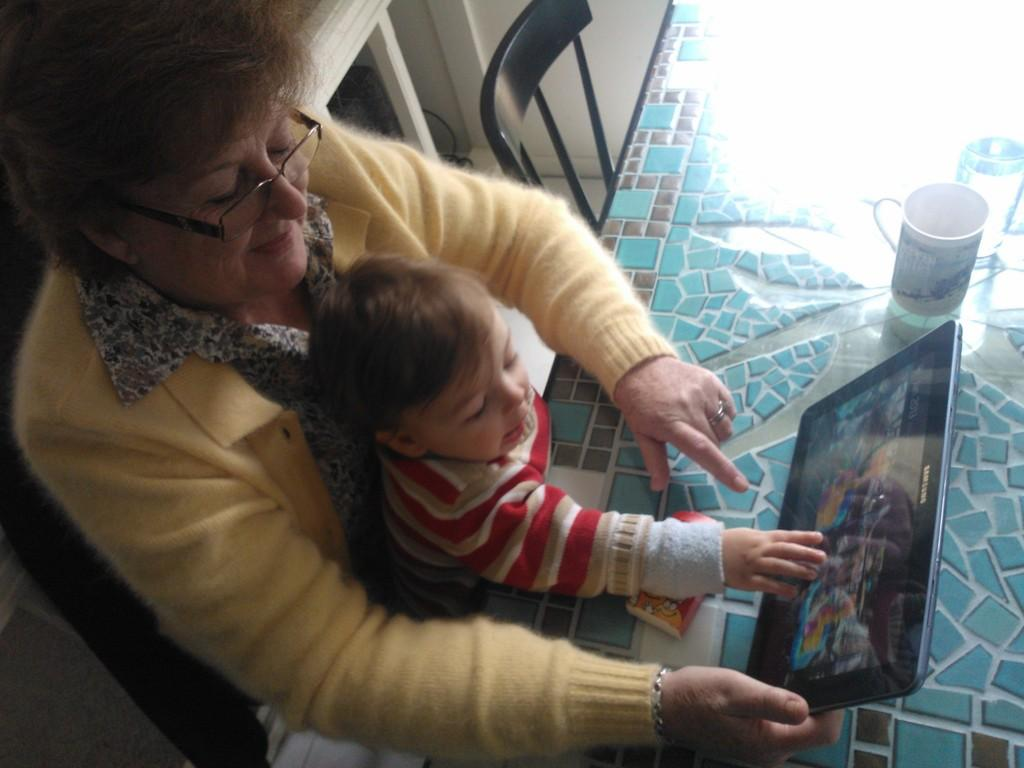How many people are in the image? There are people in the image, but the exact number is not specified. What is the lady holding in her hand? The lady is holding an electronic gadget in her hand. What can be seen on the table in the image? There are objects on a table in the image. Where is the chair located in the image? The chair is at the top of the image. What idea is being discussed by the people in the image? There is no information about any ideas being discussed in the image. The facts only mention the presence of people and a lady holding an electronic gadget. 